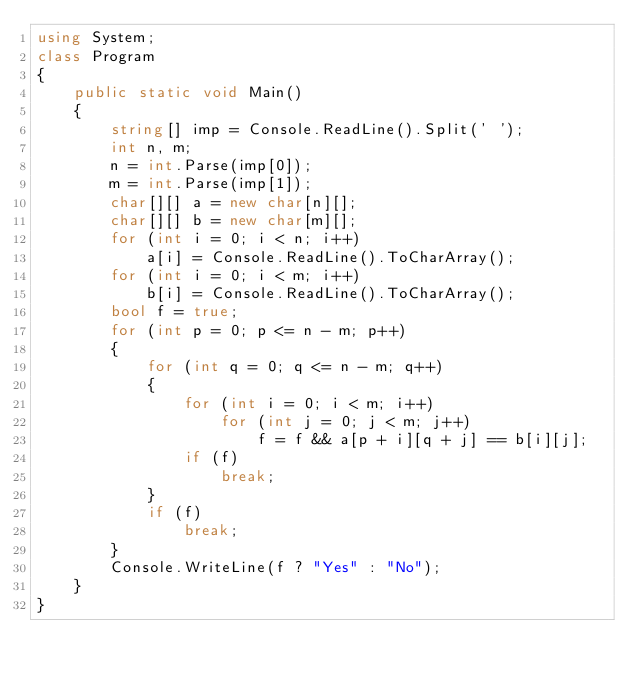Convert code to text. <code><loc_0><loc_0><loc_500><loc_500><_C#_>using System;
class Program
{
    public static void Main()
    {
        string[] imp = Console.ReadLine().Split(' ');
        int n, m;
        n = int.Parse(imp[0]);
        m = int.Parse(imp[1]);
        char[][] a = new char[n][];
        char[][] b = new char[m][];
        for (int i = 0; i < n; i++)
            a[i] = Console.ReadLine().ToCharArray();
        for (int i = 0; i < m; i++)
            b[i] = Console.ReadLine().ToCharArray();
        bool f = true;
        for (int p = 0; p <= n - m; p++)
        {
            for (int q = 0; q <= n - m; q++)
            {
                for (int i = 0; i < m; i++)
                    for (int j = 0; j < m; j++)
                        f = f && a[p + i][q + j] == b[i][j];
                if (f)
                    break;
            }
            if (f)
                break;
        }
        Console.WriteLine(f ? "Yes" : "No");
    }
}</code> 